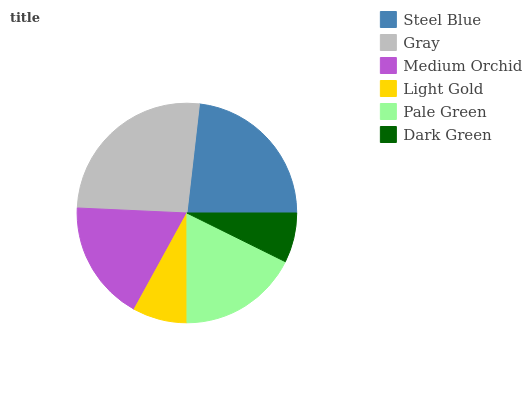Is Dark Green the minimum?
Answer yes or no. Yes. Is Gray the maximum?
Answer yes or no. Yes. Is Medium Orchid the minimum?
Answer yes or no. No. Is Medium Orchid the maximum?
Answer yes or no. No. Is Gray greater than Medium Orchid?
Answer yes or no. Yes. Is Medium Orchid less than Gray?
Answer yes or no. Yes. Is Medium Orchid greater than Gray?
Answer yes or no. No. Is Gray less than Medium Orchid?
Answer yes or no. No. Is Medium Orchid the high median?
Answer yes or no. Yes. Is Pale Green the low median?
Answer yes or no. Yes. Is Steel Blue the high median?
Answer yes or no. No. Is Steel Blue the low median?
Answer yes or no. No. 